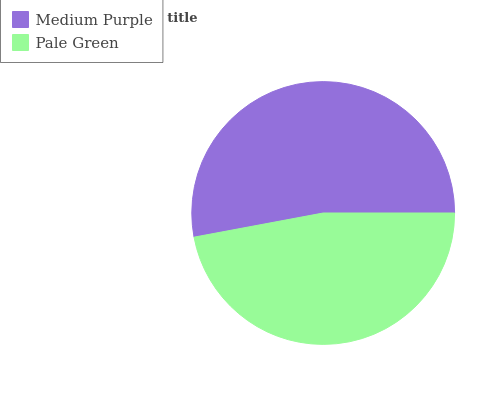Is Pale Green the minimum?
Answer yes or no. Yes. Is Medium Purple the maximum?
Answer yes or no. Yes. Is Pale Green the maximum?
Answer yes or no. No. Is Medium Purple greater than Pale Green?
Answer yes or no. Yes. Is Pale Green less than Medium Purple?
Answer yes or no. Yes. Is Pale Green greater than Medium Purple?
Answer yes or no. No. Is Medium Purple less than Pale Green?
Answer yes or no. No. Is Medium Purple the high median?
Answer yes or no. Yes. Is Pale Green the low median?
Answer yes or no. Yes. Is Pale Green the high median?
Answer yes or no. No. Is Medium Purple the low median?
Answer yes or no. No. 